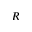<formula> <loc_0><loc_0><loc_500><loc_500>R</formula> 